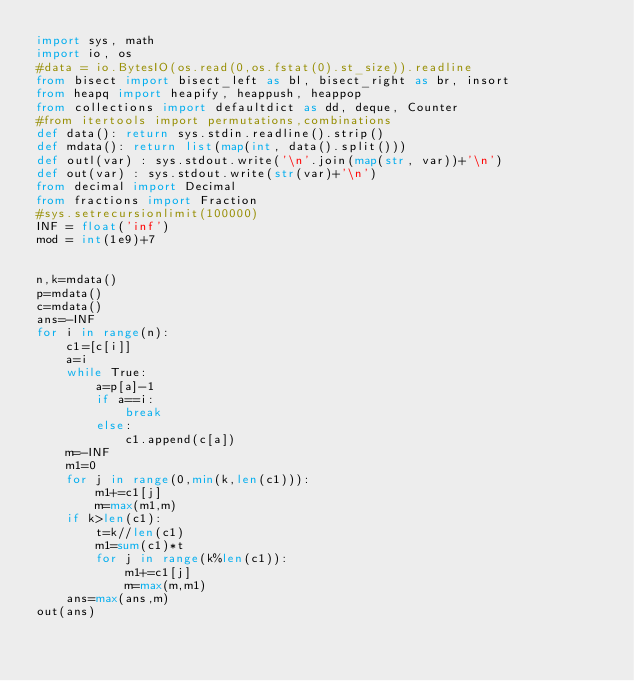<code> <loc_0><loc_0><loc_500><loc_500><_Python_>import sys, math
import io, os
#data = io.BytesIO(os.read(0,os.fstat(0).st_size)).readline
from bisect import bisect_left as bl, bisect_right as br, insort
from heapq import heapify, heappush, heappop
from collections import defaultdict as dd, deque, Counter
#from itertools import permutations,combinations
def data(): return sys.stdin.readline().strip()
def mdata(): return list(map(int, data().split()))
def outl(var) : sys.stdout.write('\n'.join(map(str, var))+'\n')
def out(var) : sys.stdout.write(str(var)+'\n')
from decimal import Decimal
from fractions import Fraction
#sys.setrecursionlimit(100000)
INF = float('inf')
mod = int(1e9)+7


n,k=mdata()
p=mdata()
c=mdata()
ans=-INF
for i in range(n):
    c1=[c[i]]
    a=i
    while True:
        a=p[a]-1
        if a==i:
            break
        else:
            c1.append(c[a])
    m=-INF
    m1=0
    for j in range(0,min(k,len(c1))):
        m1+=c1[j]
        m=max(m1,m)
    if k>len(c1):
        t=k//len(c1)
        m1=sum(c1)*t
        for j in range(k%len(c1)):
            m1+=c1[j]
            m=max(m,m1)
    ans=max(ans,m)
out(ans)

</code> 